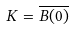Convert formula to latex. <formula><loc_0><loc_0><loc_500><loc_500>K = { \overline { B ( 0 ) } }</formula> 